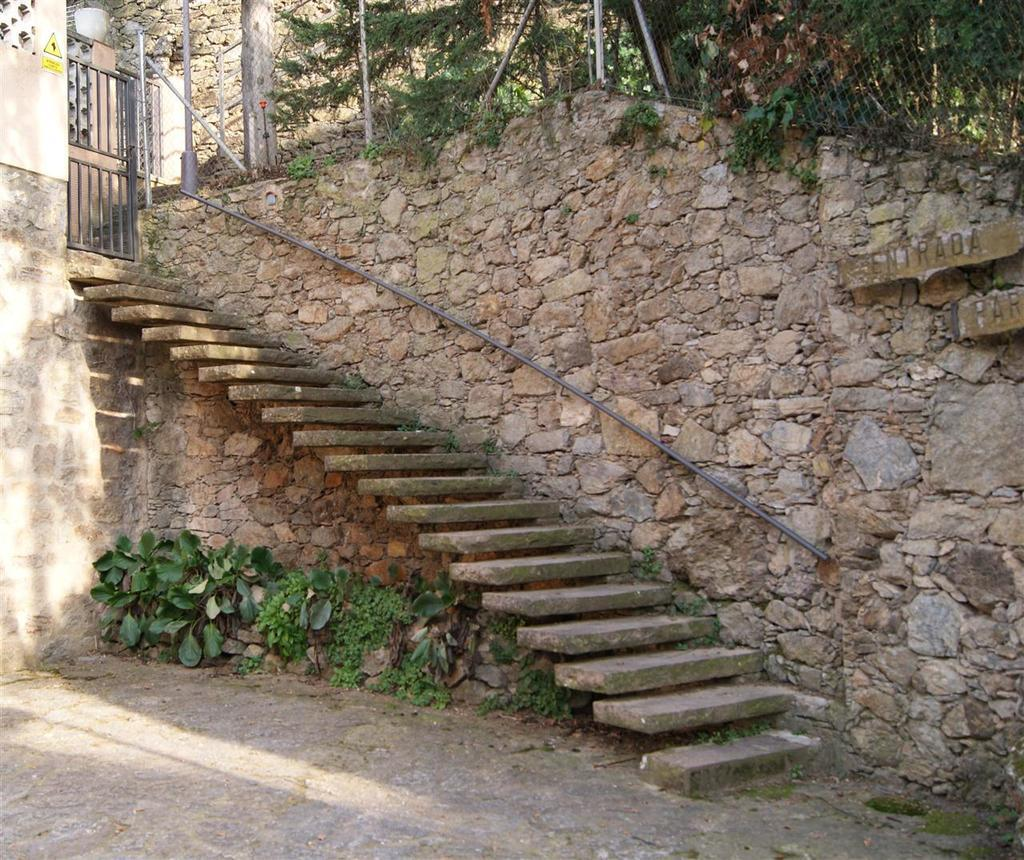What type of structure is present in the image? There are stairs in the image. Where do the stairs lead? The stairs lead to a wall. What is located under the stairs? There are plants on the ground under the stairs. What can be seen in the distance at the top of the image? There are trees visible at the top of the image. What type of entrance is present in the image? There is a gate in the image. Which actor is performing on the stairs in the image? There is no actor performing on the stairs in the image; it is a photograph of stairs, a wall, plants, trees, and a gate. 